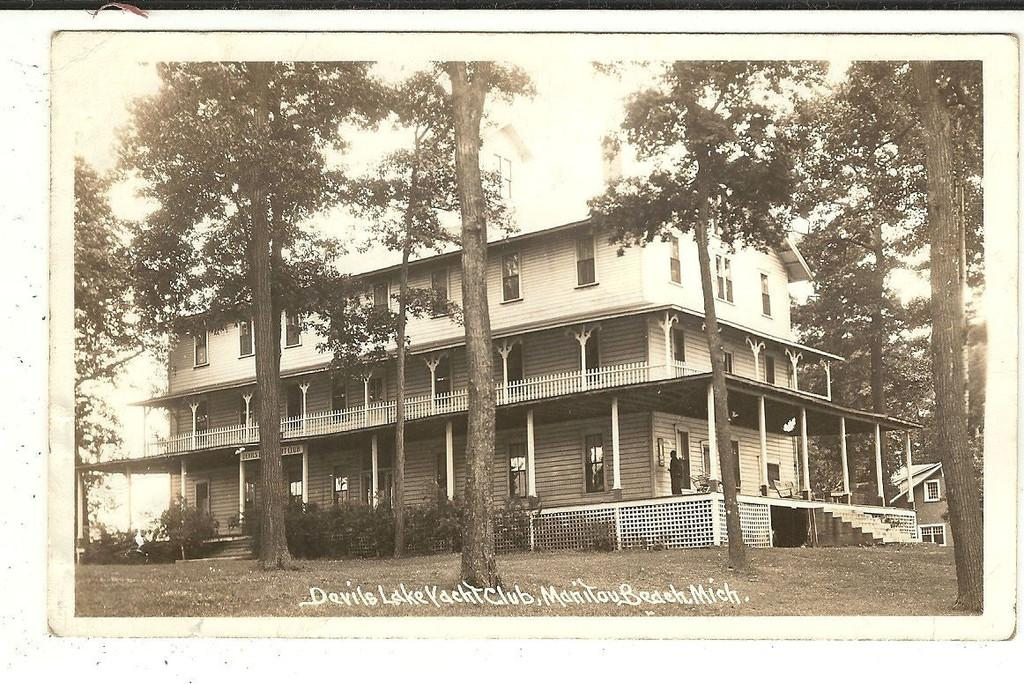What type of natural elements can be seen in the image? There are trees and plants in the image. What type of man-made structures are present in the image? There are buildings, stairs, and pillars in the image. Can you describe the person in the image? There is a person standing near the building in the image. What type of barrier is present in the image? There is a fence in the image. What is visible in the background of the image? The sky is visible in the background of the image. How many questions are being asked by the person in the image? There is no indication in the image that the person is asking any questions. What type of animals can be seen interacting with the fence in the image? There are no animals present in the image, let alone interacting with the fence. 